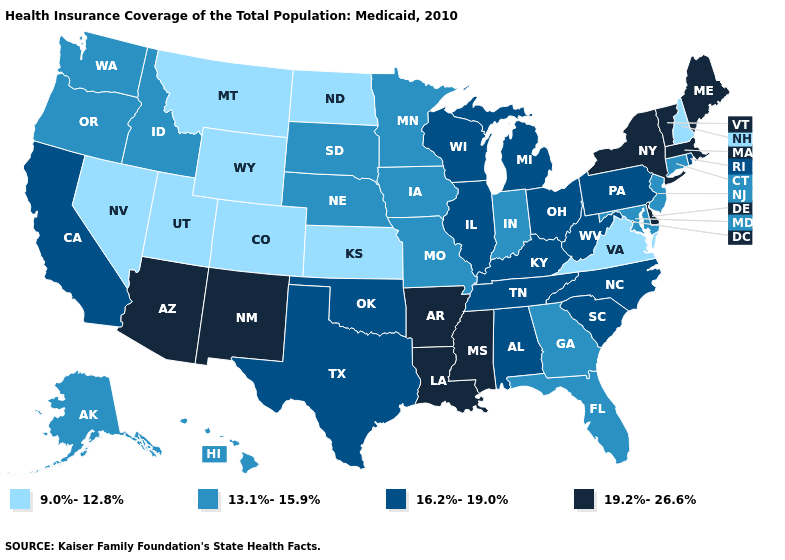Among the states that border Utah , which have the lowest value?
Quick response, please. Colorado, Nevada, Wyoming. Among the states that border Nevada , does California have the highest value?
Keep it brief. No. Does the first symbol in the legend represent the smallest category?
Give a very brief answer. Yes. Among the states that border Ohio , does Kentucky have the highest value?
Answer briefly. Yes. Among the states that border Missouri , does Kentucky have the lowest value?
Give a very brief answer. No. Name the states that have a value in the range 9.0%-12.8%?
Concise answer only. Colorado, Kansas, Montana, Nevada, New Hampshire, North Dakota, Utah, Virginia, Wyoming. Does Connecticut have the same value as Rhode Island?
Give a very brief answer. No. What is the value of Kentucky?
Write a very short answer. 16.2%-19.0%. How many symbols are there in the legend?
Answer briefly. 4. Does Hawaii have the highest value in the USA?
Quick response, please. No. What is the lowest value in the USA?
Give a very brief answer. 9.0%-12.8%. What is the value of Utah?
Give a very brief answer. 9.0%-12.8%. Does the first symbol in the legend represent the smallest category?
Answer briefly. Yes. Among the states that border Ohio , which have the lowest value?
Keep it brief. Indiana. Name the states that have a value in the range 19.2%-26.6%?
Concise answer only. Arizona, Arkansas, Delaware, Louisiana, Maine, Massachusetts, Mississippi, New Mexico, New York, Vermont. 